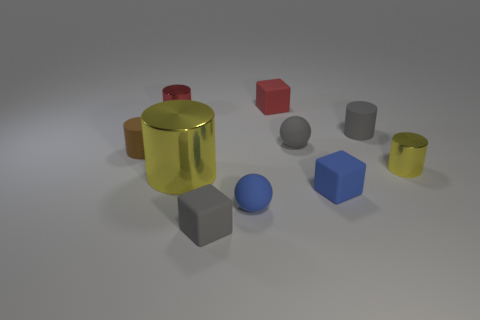Subtract all red cylinders. How many cylinders are left? 4 Subtract all tiny red cylinders. How many cylinders are left? 4 Subtract all red cylinders. Subtract all blue blocks. How many cylinders are left? 4 Subtract all spheres. How many objects are left? 8 Add 4 big yellow cylinders. How many big yellow cylinders exist? 5 Subtract 0 cyan spheres. How many objects are left? 10 Subtract all small rubber spheres. Subtract all small brown rubber objects. How many objects are left? 7 Add 9 big metallic cylinders. How many big metallic cylinders are left? 10 